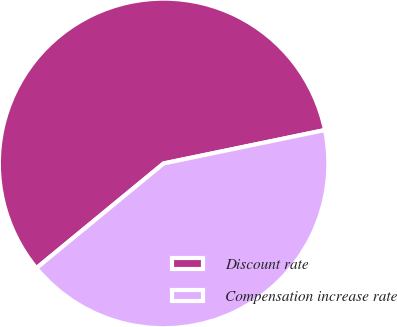Convert chart. <chart><loc_0><loc_0><loc_500><loc_500><pie_chart><fcel>Discount rate<fcel>Compensation increase rate<nl><fcel>57.71%<fcel>42.29%<nl></chart> 